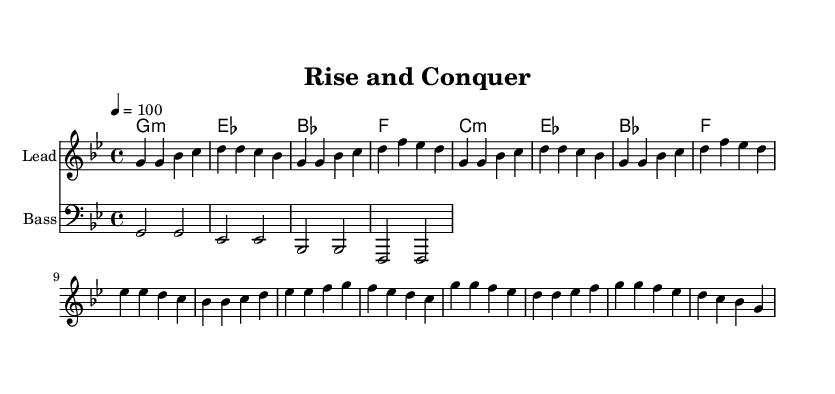What is the key signature of this music? The key signature is indicated at the beginning of the music notation. The key signature has two flats, which corresponds to the key of G minor.
Answer: G minor What is the time signature of this piece? The time signature is shown at the beginning, indicating how many beats are in each measure. In this case, it is 4/4, meaning there are four beats per measure.
Answer: 4/4 What is the tempo marking for this piece? The tempo marking is specified in beats per minute, which dictates the speed of the music. It shows "4 = 100," meaning there are 100 beats per minute.
Answer: 100 How many sections are there in "Rise and Conquer"? The structure showcases musical sections, which can be identified in the sheet music. It includes an Intro, Verse, Pre-Chorus, and Chorus, making it four distinct sections.
Answer: 4 What instrument is primarily featured in the melody? The melody staff is labeled "Lead," indicating that it is for a lead instrument, such as a synth or a vocal line, typical for hip-hop music.
Answer: Lead What chord is played during the Chorus section? The Chorus section features a specific set of chords that can be analyzed from the chord symbols written above the staff. The first chord in the Chorus is G minor.
Answer: G minor What characteristic is highlighted by using bass lines in this music? The inclusion of a bass line emphasizes the rhythmic and harmonic foundation typical in hip-hop genres, creating a fuller sound that supports the lead melody.
Answer: Rhythmic foundation 